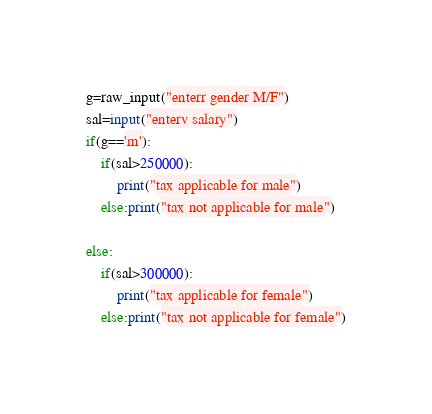<code> <loc_0><loc_0><loc_500><loc_500><_Python_>g=raw_input("enterr gender M/F")
sal=input("enterv salary")
if(g=='m'):
    if(sal>250000):
        print("tax applicable for male")
    else:print("tax not applicable for male")

else:
    if(sal>300000):
        print("tax applicable for female")
    else:print("tax not applicable for female")
</code> 